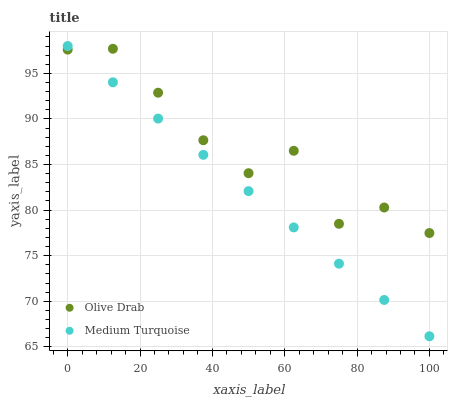Does Medium Turquoise have the minimum area under the curve?
Answer yes or no. Yes. Does Olive Drab have the maximum area under the curve?
Answer yes or no. Yes. Does Olive Drab have the minimum area under the curve?
Answer yes or no. No. Is Medium Turquoise the smoothest?
Answer yes or no. Yes. Is Olive Drab the roughest?
Answer yes or no. Yes. Is Olive Drab the smoothest?
Answer yes or no. No. Does Medium Turquoise have the lowest value?
Answer yes or no. Yes. Does Olive Drab have the lowest value?
Answer yes or no. No. Does Medium Turquoise have the highest value?
Answer yes or no. Yes. Does Olive Drab have the highest value?
Answer yes or no. No. Does Olive Drab intersect Medium Turquoise?
Answer yes or no. Yes. Is Olive Drab less than Medium Turquoise?
Answer yes or no. No. Is Olive Drab greater than Medium Turquoise?
Answer yes or no. No. 